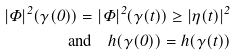Convert formula to latex. <formula><loc_0><loc_0><loc_500><loc_500>| \Phi | ^ { 2 } ( \gamma ( 0 ) ) = | \Phi | ^ { 2 } ( \gamma ( t ) ) \geq | \eta ( t ) | ^ { 2 } \\ \text {and} \quad h ( \gamma ( 0 ) ) = h ( \gamma ( t ) )</formula> 